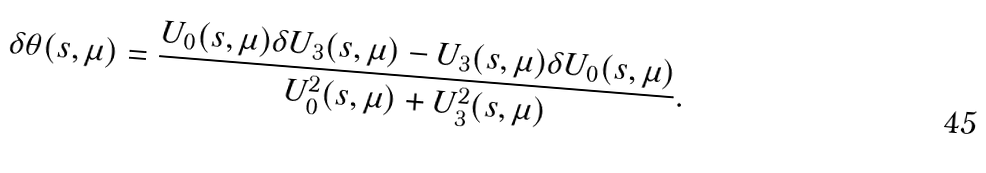<formula> <loc_0><loc_0><loc_500><loc_500>\delta \theta ( s , \mu ) = \frac { U _ { 0 } ( s , \mu ) \delta U _ { 3 } ( s , \mu ) - U _ { 3 } ( s , \mu ) \delta U _ { 0 } ( s , \mu ) } { U _ { 0 } ^ { 2 } ( s , \mu ) + U _ { 3 } ^ { 2 } ( s , \mu ) } .</formula> 